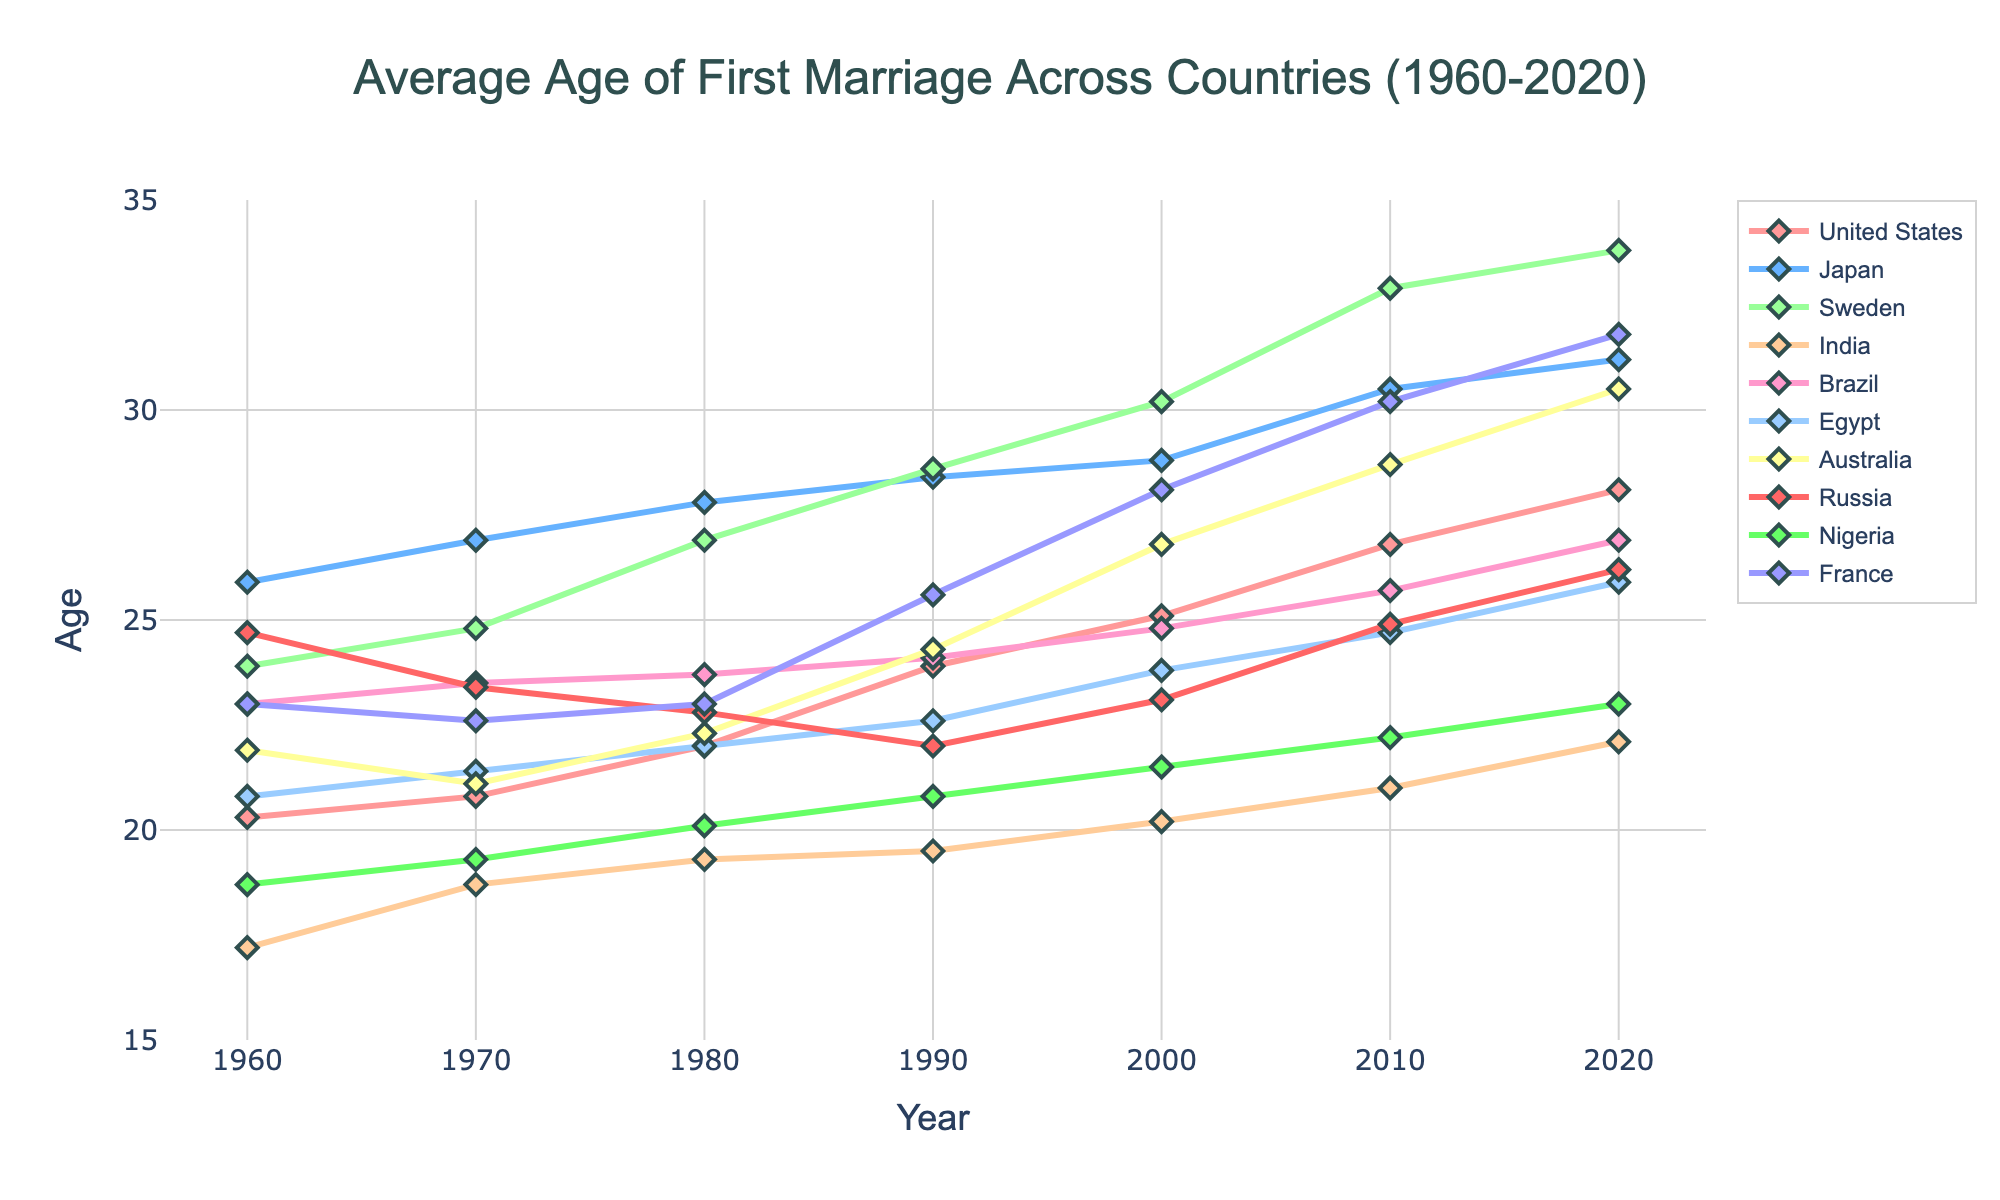What's the difference in the average age of first marriage between Japan and Australia in 2020? In 2020, Japan's average age is 31.2 years and Australia's is 30.5 years. So, 31.2 - 30.5 gives the difference.
Answer: 0.7 years Which two countries have the largest increase in the average age of first marriage from 1960 to 2020? Comparing the lines from 1960 to 2020, Sweden shows an increase from 23.9 to 33.8 (9.9 years), and the United States from 20.3 to 28.1 (7.8 years).
Answer: Sweden and the United States What is the range of ages for Russia's average age of first marriage from 1960 to 2020? The lowest point for Russia is in 1990 at 22.0 years, and the highest is around 2020 at 26.2 years. Calculating the range: 26.2 - 22.0
Answer: 4.2 years Which country had a higher average age of first marriage in 1960, Japan or France? The line for Japan in 1960 is at 25.9 years, while France is at 23.0 years.
Answer: Japan Has Nigeria's average age of first marriage experienced a steady increase from 1960 to 2020? The trend line for Nigeria shows a gradual increase from 18.7 in 1960 to 23.0 in 2020 without significant drops, indicating a steady rise.
Answer: Yes What is the average age difference of first marriages between Sweden and India in 2020? Sweden's average age for 2020 is 33.8, while India's is 22.1. Subtracting 22.1 from 33.8 gives the difference.
Answer: 11.7 years 